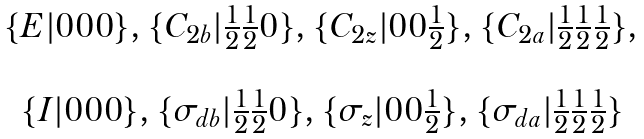<formula> <loc_0><loc_0><loc_500><loc_500>\begin{array} { c } \{ E | 0 0 0 \} , \{ C _ { 2 b } | \frac { 1 } { 2 } \frac { 1 } { 2 } 0 \} , \{ C _ { 2 z } | 0 0 \frac { 1 } { 2 } \} , \{ C _ { 2 a } | \frac { 1 } { 2 } \frac { 1 } { 2 } \frac { 1 } { 2 } \} , \\ \\ \{ I | 0 0 0 \} , \{ \sigma _ { d b } | \frac { 1 } { 2 } \frac { 1 } { 2 } 0 \} , \{ \sigma _ { z } | 0 0 \frac { 1 } { 2 } \} , \{ \sigma _ { d a } | \frac { 1 } { 2 } \frac { 1 } { 2 } \frac { 1 } { 2 } \} \end{array}</formula> 